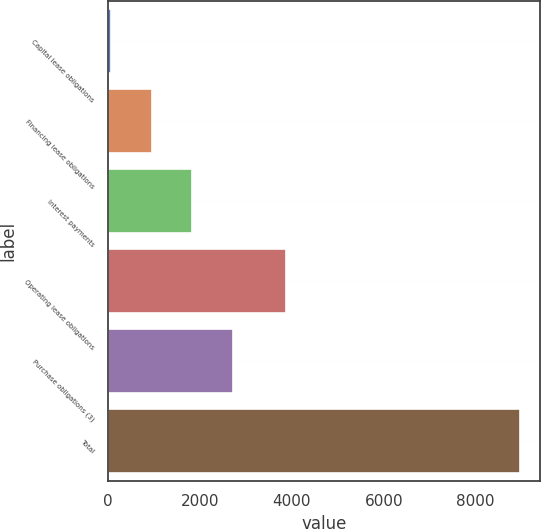Convert chart. <chart><loc_0><loc_0><loc_500><loc_500><bar_chart><fcel>Capital lease obligations<fcel>Financing lease obligations<fcel>Interest payments<fcel>Operating lease obligations<fcel>Purchase obligations (3)<fcel>Total<nl><fcel>52<fcel>942.4<fcel>1832.8<fcel>3876<fcel>2723.2<fcel>8956<nl></chart> 